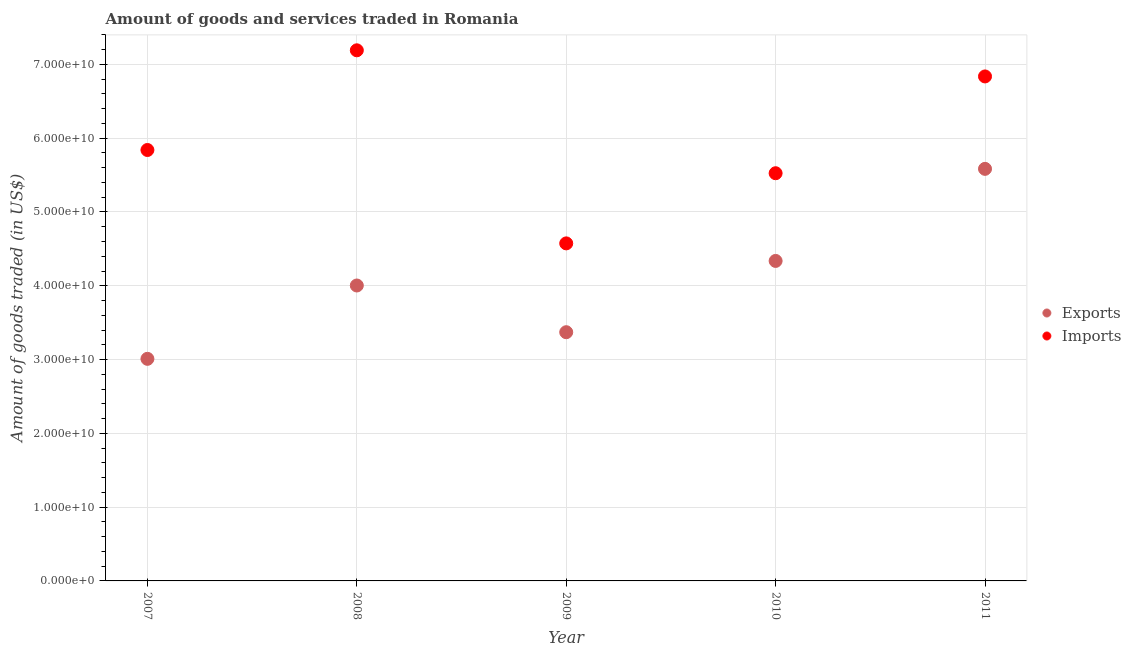How many different coloured dotlines are there?
Your response must be concise. 2. Is the number of dotlines equal to the number of legend labels?
Your answer should be very brief. Yes. What is the amount of goods imported in 2011?
Provide a succinct answer. 6.84e+1. Across all years, what is the maximum amount of goods imported?
Provide a short and direct response. 7.19e+1. Across all years, what is the minimum amount of goods exported?
Your answer should be very brief. 3.01e+1. In which year was the amount of goods exported maximum?
Your answer should be compact. 2011. In which year was the amount of goods imported minimum?
Your response must be concise. 2009. What is the total amount of goods imported in the graph?
Keep it short and to the point. 3.00e+11. What is the difference between the amount of goods exported in 2009 and that in 2010?
Provide a short and direct response. -9.66e+09. What is the difference between the amount of goods exported in 2010 and the amount of goods imported in 2009?
Your response must be concise. -2.38e+09. What is the average amount of goods exported per year?
Provide a succinct answer. 4.06e+1. In the year 2010, what is the difference between the amount of goods exported and amount of goods imported?
Offer a very short reply. -1.19e+1. In how many years, is the amount of goods imported greater than 30000000000 US$?
Your response must be concise. 5. What is the ratio of the amount of goods exported in 2010 to that in 2011?
Keep it short and to the point. 0.78. Is the amount of goods exported in 2009 less than that in 2010?
Offer a terse response. Yes. Is the difference between the amount of goods exported in 2008 and 2009 greater than the difference between the amount of goods imported in 2008 and 2009?
Offer a very short reply. No. What is the difference between the highest and the second highest amount of goods exported?
Ensure brevity in your answer.  1.25e+1. What is the difference between the highest and the lowest amount of goods imported?
Offer a terse response. 2.62e+1. In how many years, is the amount of goods imported greater than the average amount of goods imported taken over all years?
Your answer should be compact. 2. Is the sum of the amount of goods imported in 2007 and 2011 greater than the maximum amount of goods exported across all years?
Give a very brief answer. Yes. Is the amount of goods imported strictly greater than the amount of goods exported over the years?
Give a very brief answer. Yes. Is the amount of goods imported strictly less than the amount of goods exported over the years?
Ensure brevity in your answer.  No. How many years are there in the graph?
Ensure brevity in your answer.  5. What is the difference between two consecutive major ticks on the Y-axis?
Ensure brevity in your answer.  1.00e+1. Does the graph contain any zero values?
Ensure brevity in your answer.  No. Does the graph contain grids?
Provide a succinct answer. Yes. What is the title of the graph?
Give a very brief answer. Amount of goods and services traded in Romania. What is the label or title of the X-axis?
Offer a terse response. Year. What is the label or title of the Y-axis?
Keep it short and to the point. Amount of goods traded (in US$). What is the Amount of goods traded (in US$) of Exports in 2007?
Offer a terse response. 3.01e+1. What is the Amount of goods traded (in US$) in Imports in 2007?
Keep it short and to the point. 5.84e+1. What is the Amount of goods traded (in US$) of Exports in 2008?
Offer a terse response. 4.00e+1. What is the Amount of goods traded (in US$) of Imports in 2008?
Keep it short and to the point. 7.19e+1. What is the Amount of goods traded (in US$) in Exports in 2009?
Your answer should be compact. 3.37e+1. What is the Amount of goods traded (in US$) in Imports in 2009?
Provide a succinct answer. 4.57e+1. What is the Amount of goods traded (in US$) in Exports in 2010?
Ensure brevity in your answer.  4.34e+1. What is the Amount of goods traded (in US$) in Imports in 2010?
Offer a terse response. 5.53e+1. What is the Amount of goods traded (in US$) of Exports in 2011?
Ensure brevity in your answer.  5.58e+1. What is the Amount of goods traded (in US$) in Imports in 2011?
Your answer should be very brief. 6.84e+1. Across all years, what is the maximum Amount of goods traded (in US$) in Exports?
Your answer should be very brief. 5.58e+1. Across all years, what is the maximum Amount of goods traded (in US$) of Imports?
Provide a succinct answer. 7.19e+1. Across all years, what is the minimum Amount of goods traded (in US$) of Exports?
Offer a very short reply. 3.01e+1. Across all years, what is the minimum Amount of goods traded (in US$) of Imports?
Provide a short and direct response. 4.57e+1. What is the total Amount of goods traded (in US$) of Exports in the graph?
Offer a terse response. 2.03e+11. What is the total Amount of goods traded (in US$) of Imports in the graph?
Make the answer very short. 3.00e+11. What is the difference between the Amount of goods traded (in US$) in Exports in 2007 and that in 2008?
Make the answer very short. -9.94e+09. What is the difference between the Amount of goods traded (in US$) in Imports in 2007 and that in 2008?
Make the answer very short. -1.35e+1. What is the difference between the Amount of goods traded (in US$) of Exports in 2007 and that in 2009?
Provide a short and direct response. -3.61e+09. What is the difference between the Amount of goods traded (in US$) of Imports in 2007 and that in 2009?
Your answer should be compact. 1.27e+1. What is the difference between the Amount of goods traded (in US$) of Exports in 2007 and that in 2010?
Give a very brief answer. -1.33e+1. What is the difference between the Amount of goods traded (in US$) in Imports in 2007 and that in 2010?
Your answer should be very brief. 3.15e+09. What is the difference between the Amount of goods traded (in US$) in Exports in 2007 and that in 2011?
Provide a short and direct response. -2.57e+1. What is the difference between the Amount of goods traded (in US$) of Imports in 2007 and that in 2011?
Offer a very short reply. -9.97e+09. What is the difference between the Amount of goods traded (in US$) in Exports in 2008 and that in 2009?
Keep it short and to the point. 6.33e+09. What is the difference between the Amount of goods traded (in US$) of Imports in 2008 and that in 2009?
Your response must be concise. 2.62e+1. What is the difference between the Amount of goods traded (in US$) in Exports in 2008 and that in 2010?
Ensure brevity in your answer.  -3.33e+09. What is the difference between the Amount of goods traded (in US$) in Imports in 2008 and that in 2010?
Provide a succinct answer. 1.67e+1. What is the difference between the Amount of goods traded (in US$) in Exports in 2008 and that in 2011?
Your answer should be very brief. -1.58e+1. What is the difference between the Amount of goods traded (in US$) of Imports in 2008 and that in 2011?
Make the answer very short. 3.54e+09. What is the difference between the Amount of goods traded (in US$) of Exports in 2009 and that in 2010?
Your answer should be compact. -9.66e+09. What is the difference between the Amount of goods traded (in US$) of Imports in 2009 and that in 2010?
Your answer should be compact. -9.51e+09. What is the difference between the Amount of goods traded (in US$) in Exports in 2009 and that in 2011?
Provide a succinct answer. -2.21e+1. What is the difference between the Amount of goods traded (in US$) in Imports in 2009 and that in 2011?
Keep it short and to the point. -2.26e+1. What is the difference between the Amount of goods traded (in US$) of Exports in 2010 and that in 2011?
Your response must be concise. -1.25e+1. What is the difference between the Amount of goods traded (in US$) of Imports in 2010 and that in 2011?
Offer a terse response. -1.31e+1. What is the difference between the Amount of goods traded (in US$) of Exports in 2007 and the Amount of goods traded (in US$) of Imports in 2008?
Give a very brief answer. -4.18e+1. What is the difference between the Amount of goods traded (in US$) of Exports in 2007 and the Amount of goods traded (in US$) of Imports in 2009?
Make the answer very short. -1.56e+1. What is the difference between the Amount of goods traded (in US$) in Exports in 2007 and the Amount of goods traded (in US$) in Imports in 2010?
Offer a terse response. -2.52e+1. What is the difference between the Amount of goods traded (in US$) in Exports in 2007 and the Amount of goods traded (in US$) in Imports in 2011?
Give a very brief answer. -3.83e+1. What is the difference between the Amount of goods traded (in US$) of Exports in 2008 and the Amount of goods traded (in US$) of Imports in 2009?
Keep it short and to the point. -5.71e+09. What is the difference between the Amount of goods traded (in US$) in Exports in 2008 and the Amount of goods traded (in US$) in Imports in 2010?
Make the answer very short. -1.52e+1. What is the difference between the Amount of goods traded (in US$) in Exports in 2008 and the Amount of goods traded (in US$) in Imports in 2011?
Your answer should be very brief. -2.83e+1. What is the difference between the Amount of goods traded (in US$) in Exports in 2009 and the Amount of goods traded (in US$) in Imports in 2010?
Offer a terse response. -2.15e+1. What is the difference between the Amount of goods traded (in US$) in Exports in 2009 and the Amount of goods traded (in US$) in Imports in 2011?
Make the answer very short. -3.47e+1. What is the difference between the Amount of goods traded (in US$) in Exports in 2010 and the Amount of goods traded (in US$) in Imports in 2011?
Provide a short and direct response. -2.50e+1. What is the average Amount of goods traded (in US$) of Exports per year?
Provide a short and direct response. 4.06e+1. What is the average Amount of goods traded (in US$) in Imports per year?
Your answer should be compact. 5.99e+1. In the year 2007, what is the difference between the Amount of goods traded (in US$) of Exports and Amount of goods traded (in US$) of Imports?
Give a very brief answer. -2.83e+1. In the year 2008, what is the difference between the Amount of goods traded (in US$) of Exports and Amount of goods traded (in US$) of Imports?
Give a very brief answer. -3.19e+1. In the year 2009, what is the difference between the Amount of goods traded (in US$) of Exports and Amount of goods traded (in US$) of Imports?
Your answer should be compact. -1.20e+1. In the year 2010, what is the difference between the Amount of goods traded (in US$) in Exports and Amount of goods traded (in US$) in Imports?
Provide a succinct answer. -1.19e+1. In the year 2011, what is the difference between the Amount of goods traded (in US$) of Exports and Amount of goods traded (in US$) of Imports?
Provide a short and direct response. -1.25e+1. What is the ratio of the Amount of goods traded (in US$) of Exports in 2007 to that in 2008?
Keep it short and to the point. 0.75. What is the ratio of the Amount of goods traded (in US$) of Imports in 2007 to that in 2008?
Ensure brevity in your answer.  0.81. What is the ratio of the Amount of goods traded (in US$) in Exports in 2007 to that in 2009?
Ensure brevity in your answer.  0.89. What is the ratio of the Amount of goods traded (in US$) in Imports in 2007 to that in 2009?
Make the answer very short. 1.28. What is the ratio of the Amount of goods traded (in US$) in Exports in 2007 to that in 2010?
Provide a succinct answer. 0.69. What is the ratio of the Amount of goods traded (in US$) in Imports in 2007 to that in 2010?
Your response must be concise. 1.06. What is the ratio of the Amount of goods traded (in US$) of Exports in 2007 to that in 2011?
Your answer should be compact. 0.54. What is the ratio of the Amount of goods traded (in US$) of Imports in 2007 to that in 2011?
Keep it short and to the point. 0.85. What is the ratio of the Amount of goods traded (in US$) of Exports in 2008 to that in 2009?
Make the answer very short. 1.19. What is the ratio of the Amount of goods traded (in US$) of Imports in 2008 to that in 2009?
Keep it short and to the point. 1.57. What is the ratio of the Amount of goods traded (in US$) of Exports in 2008 to that in 2010?
Make the answer very short. 0.92. What is the ratio of the Amount of goods traded (in US$) of Imports in 2008 to that in 2010?
Your answer should be compact. 1.3. What is the ratio of the Amount of goods traded (in US$) in Exports in 2008 to that in 2011?
Provide a succinct answer. 0.72. What is the ratio of the Amount of goods traded (in US$) of Imports in 2008 to that in 2011?
Ensure brevity in your answer.  1.05. What is the ratio of the Amount of goods traded (in US$) of Exports in 2009 to that in 2010?
Offer a very short reply. 0.78. What is the ratio of the Amount of goods traded (in US$) of Imports in 2009 to that in 2010?
Your answer should be very brief. 0.83. What is the ratio of the Amount of goods traded (in US$) in Exports in 2009 to that in 2011?
Offer a very short reply. 0.6. What is the ratio of the Amount of goods traded (in US$) in Imports in 2009 to that in 2011?
Keep it short and to the point. 0.67. What is the ratio of the Amount of goods traded (in US$) of Exports in 2010 to that in 2011?
Provide a succinct answer. 0.78. What is the ratio of the Amount of goods traded (in US$) in Imports in 2010 to that in 2011?
Ensure brevity in your answer.  0.81. What is the difference between the highest and the second highest Amount of goods traded (in US$) of Exports?
Keep it short and to the point. 1.25e+1. What is the difference between the highest and the second highest Amount of goods traded (in US$) of Imports?
Make the answer very short. 3.54e+09. What is the difference between the highest and the lowest Amount of goods traded (in US$) in Exports?
Your response must be concise. 2.57e+1. What is the difference between the highest and the lowest Amount of goods traded (in US$) of Imports?
Provide a short and direct response. 2.62e+1. 